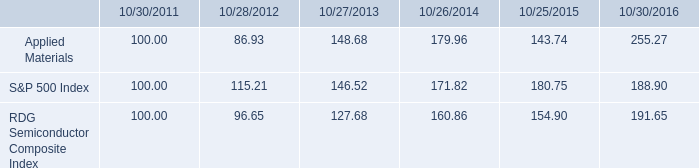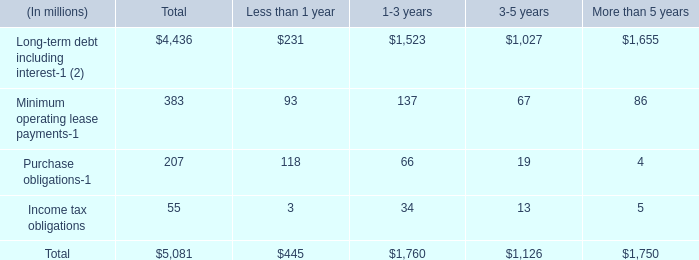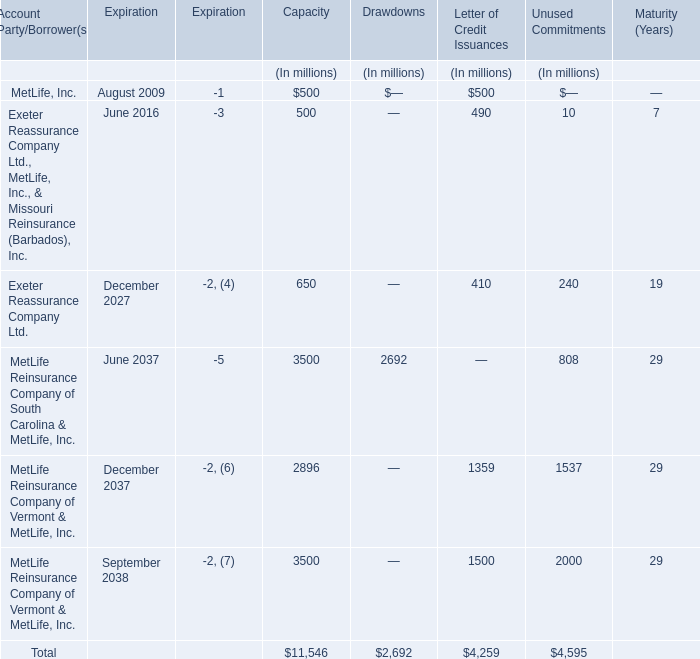What is the proportion of all Letter of Credit Issuances that are greater than 1000 to the total amount of Letter of Credit Issuances for Letter of Credit Issuances? 
Computations: ((1359 + 1500) / 4259)
Answer: 0.67128. 